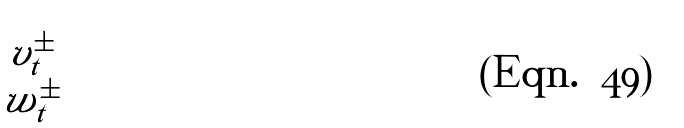<formula> <loc_0><loc_0><loc_500><loc_500>\begin{pmatrix} v ^ { \pm } _ { t } \\ w ^ { \pm } _ { t } \end{pmatrix}</formula> 